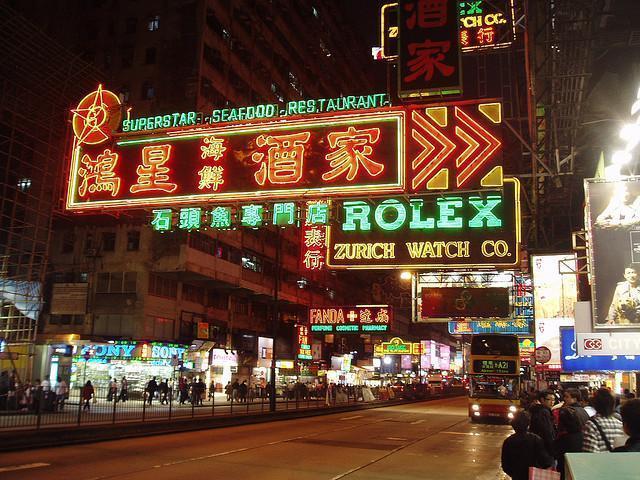How many people are there?
Give a very brief answer. 2. 